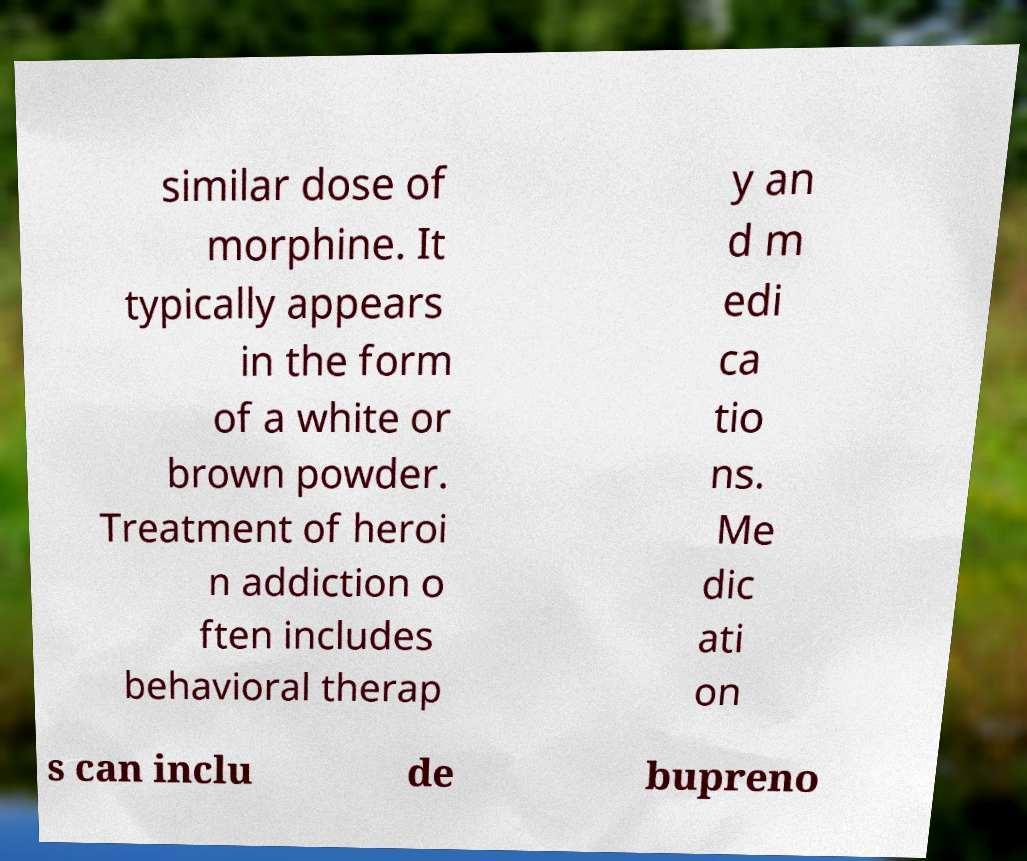Could you extract and type out the text from this image? similar dose of morphine. It typically appears in the form of a white or brown powder. Treatment of heroi n addiction o ften includes behavioral therap y an d m edi ca tio ns. Me dic ati on s can inclu de bupreno 